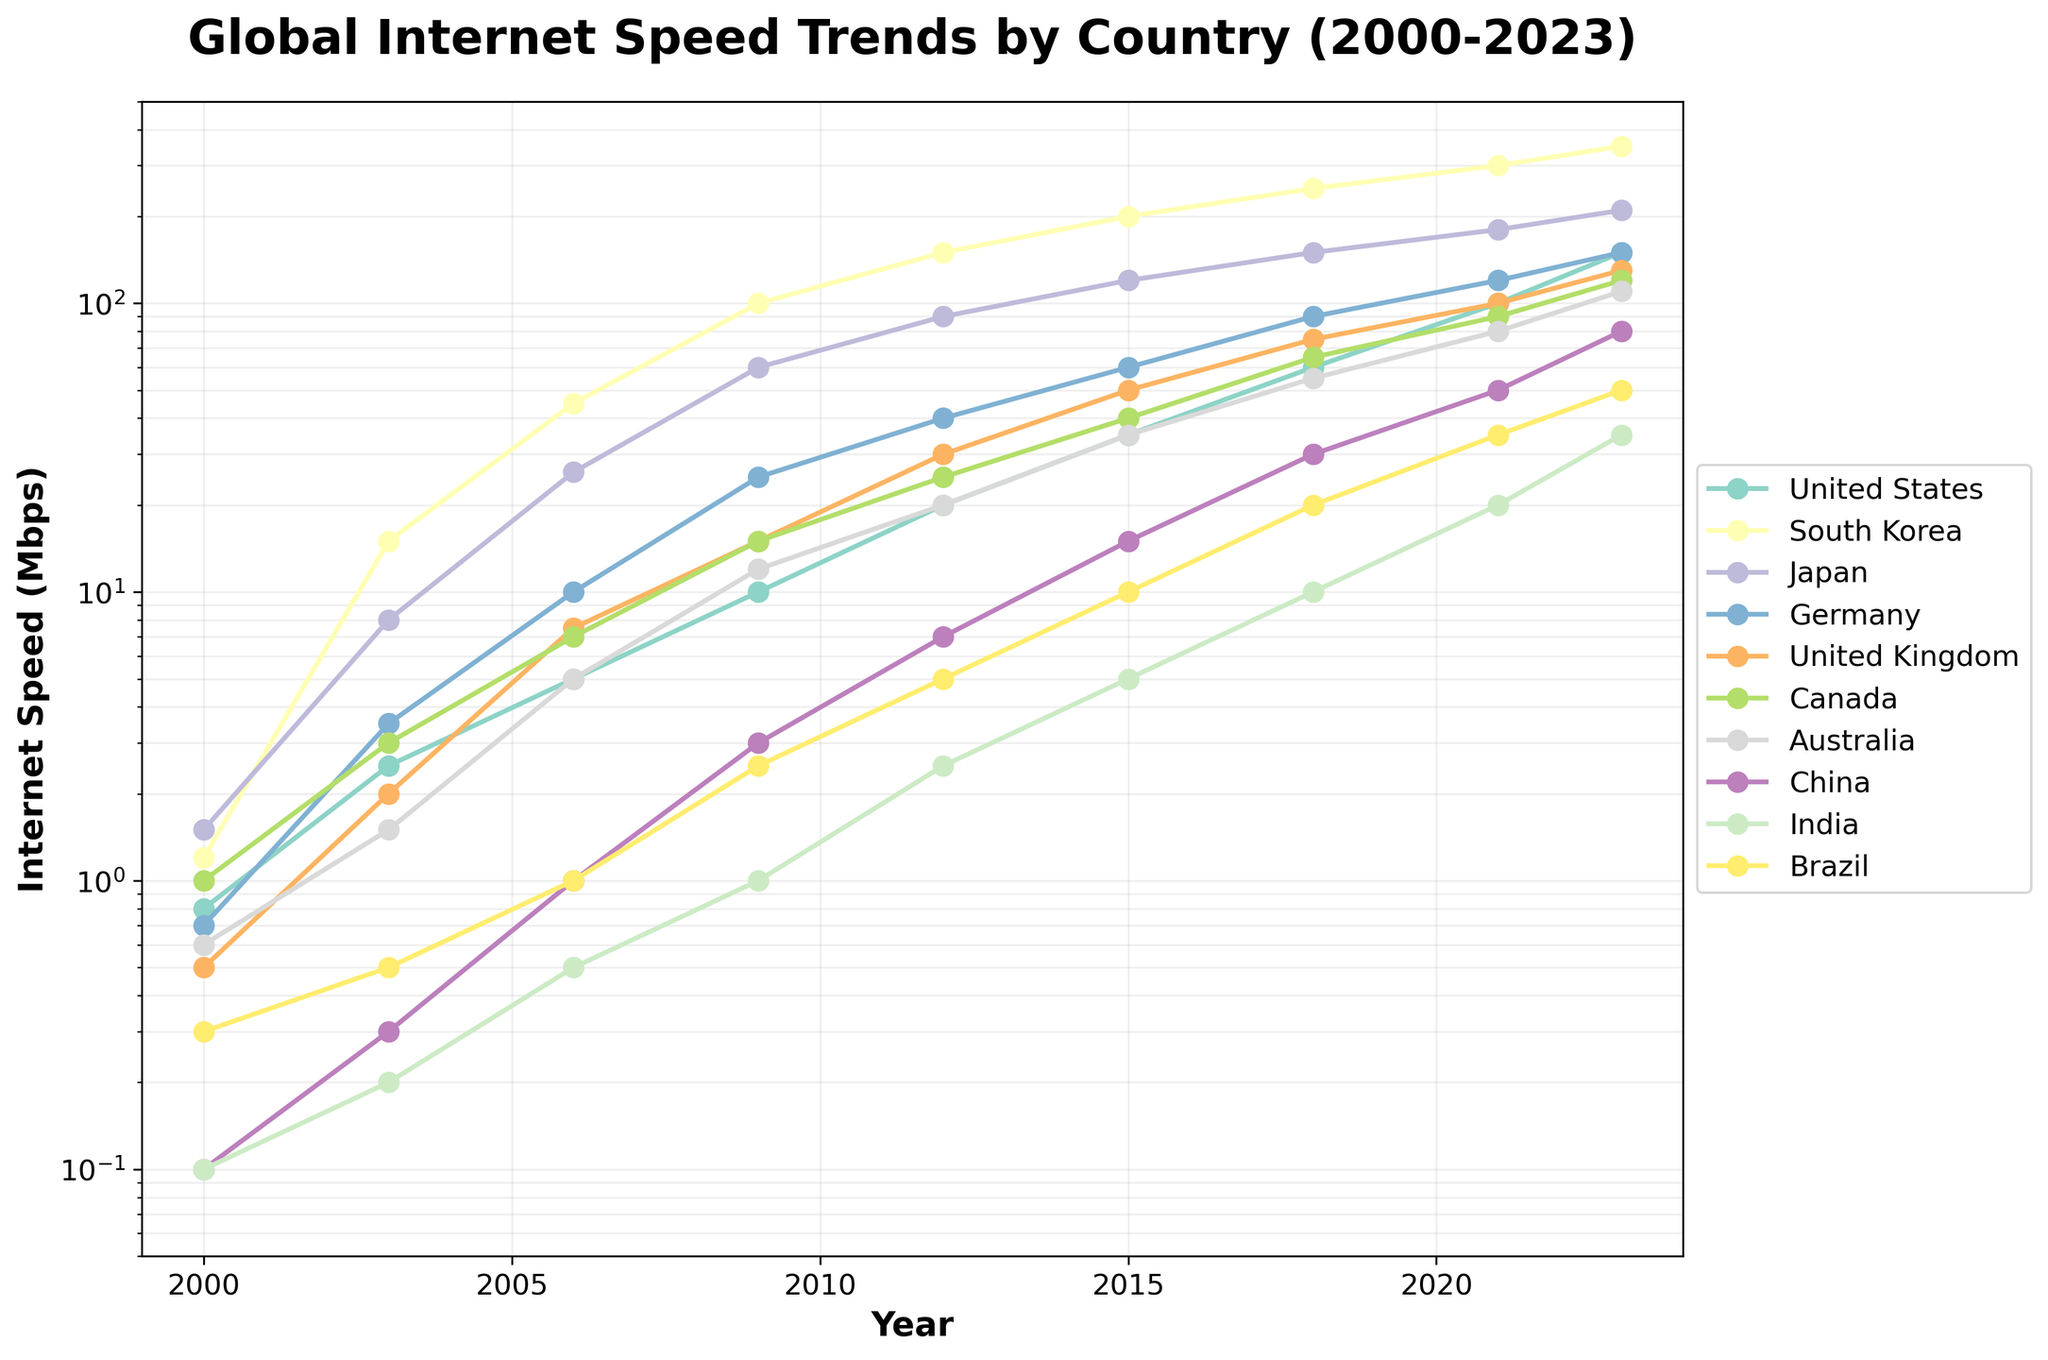Which country had the fastest internet speed in 2023? Look at the 2023 data points and identify the highest value. South Korea has the highest at 350 Mbps.
Answer: South Korea What is the difference in internet speed between the United States and China in 2023? Subtract China's 2023 value (80 Mbps) from the United States' 2023 value (150 Mbps).
Answer: 70 Mbps Which countries showed a consistent increase in internet speeds across all years? Observe the trend lines for each country from 2000 to 2023 and see which continuously rise without any dips. All the countries listed (United States, South Korea, Japan, Germany, United Kingdom, Canada, Australia, China, India, Brazil) show consistent increasing trends.
Answer: United States, South Korea, Japan, Germany, United Kingdom, Canada, Australia, China, India, Brazil Between 2009 and 2015, which country had the highest increment in internet speed? Calculate the difference for each country over these years and compare. South Korea: 200 to 100 = 100 Mbps is the highest increment.
Answer: South Korea What is the average internet speed of Germany from 2000 to 2023? Sum Germany's internet speeds across all listed years (0.7 + 3.5 + 10.0 + 25.0 + 40.0 + 60.0 + 90.0 + 120.0 + 150.0 = 499.2 Mbps). Divide by the number of data points (9).
Answer: 55.44 Mbps Which country had the lowest internet speed in the year 2000? Compare the 2000 data points for each country and identify the smallest value. China and India both have the lowest at 0.1 Mbps.
Answer: China, India How did India's internet speed in 2023 compare to its speed in 2000? Compare India's data points in 2023 (35 Mbps) and 2000 (0.1 Mbps). 35 Mbps is significantly greater than 0.1 Mbps.
Answer: Much higher in 2023 Between the United States and Germany, which country had a greater internet speed increase between 2012 and 2023? Calculate the increase for each: United States (150 - 20 = 130 Mbps), Germany (150 - 40 = 110 Mbps). Compare the two values.
Answer: United States Which country had a higher rate of increase in internet speed from 2000 to 2023: Japan or the United Kingdom? Calculate the increase: Japan (210 - 1.5 = 208.5 Mbps), United Kingdom (130 - 0.5 = 129.5 Mbps). Compare the rates.
Answer: Japan How many countries had internet speeds exceeding 100 Mbps in 2021? Identify countries whose 2021 internet speeds are above 100 Mbps (United States, South Korea, Japan, Germany, United Kingdom, Canada, Australia, China). Count these countries.
Answer: 8 